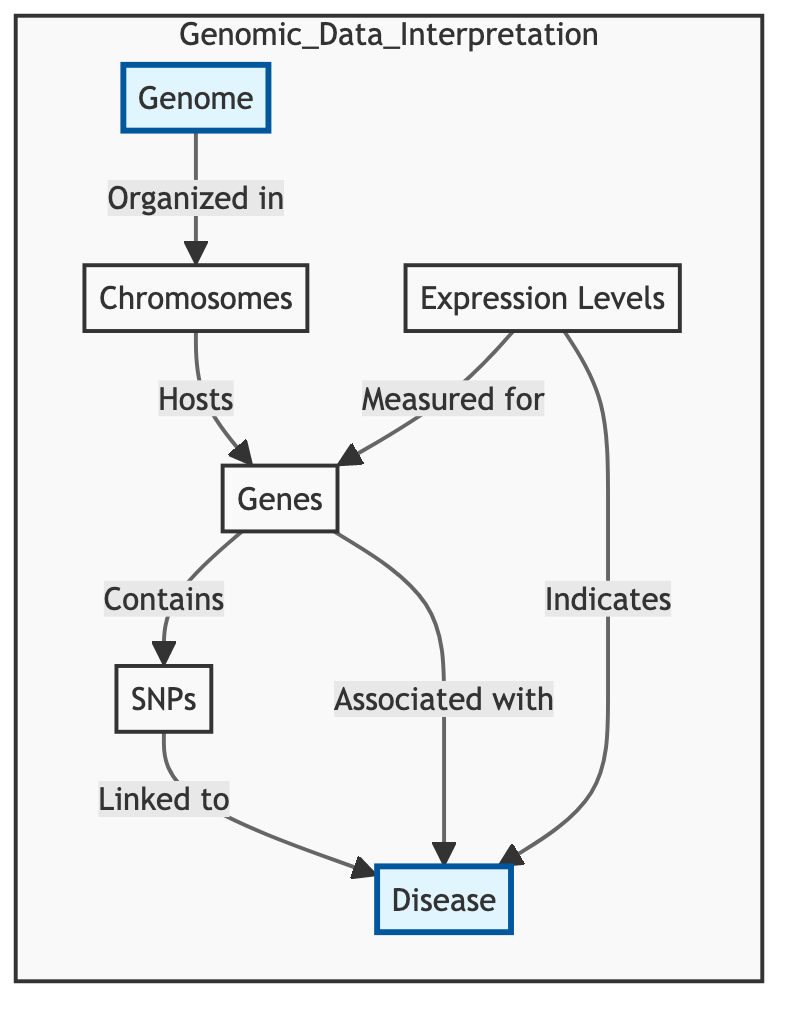What is the central focus of the diagram? The diagram emphasizes the relationship between genomic data and its association with disease, clearly highlighting "Genome" and "Disease" as key points.
Answer: Genomic Data Association How many nodes are in the diagram? By counting the distinct entities presented in the diagram, we can identify six nodes total: Genome, Chromosomes, Genes, SNPs, Disease, and Expression Levels.
Answer: 6 What relationship exists between Genes and Disease? The diagram indicates two specific relationships: Genes are linked to Disease, and they are also associated with Disease, as denoted by the arrows connecting them.
Answer: Linked and Associated Which node is directly measured for its expression levels? The diagram shows a direct relationship where Expression Levels are measured for the Genes node, indicating that Genes are the focus of expression measurement.
Answer: Genes What is the connection between SNPs and Disease? The diagram outlines that SNPs have a direct link to Disease, demonstrating how genetic variations may influence disease outcomes.
Answer: Linked to Which node serves as the primary organizer of the genomic data? The initial node labeled "Genome" is presented as the organizer for the genomic data, as it connects to all other nodes in the diagram structure.
Answer: Genome How many relationships lead from Genes to Disease? There are two distinct pathways illustrated in the diagram that show relationships leading from Genes to Disease, emphasizing the complexity of associations in genomic studies.
Answer: 2 Which component indicates the potential influence on Disease? The Expression Levels node indicates influence on Disease, as it shows that the expression levels of various genes may serve as an indicator for disease presence or severity.
Answer: Indicates What role do Chromosomes play in this genomic data framework? Chromosomes act as hosts for Genes, signifying their crucial structural role in containing the genetic material that relates to disease associations.
Answer: Hosts 